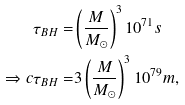Convert formula to latex. <formula><loc_0><loc_0><loc_500><loc_500>\tau _ { B H } = & \left ( \frac { M } { M _ { \odot } } \right ) ^ { 3 } 1 0 ^ { 7 1 } s \\ \Rightarrow c \tau _ { B H } = & 3 \left ( \frac { M } { M _ { \odot } } \right ) ^ { 3 } 1 0 ^ { 7 9 } m ,</formula> 